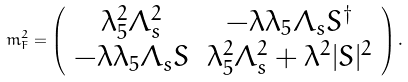<formula> <loc_0><loc_0><loc_500><loc_500>m _ { F } ^ { 2 } = \left ( \begin{array} { c c } \lambda _ { 5 } ^ { 2 } \Lambda _ { s } ^ { 2 } & - \lambda \lambda _ { 5 } \Lambda _ { s } S ^ { \dagger } \\ - \lambda \lambda _ { 5 } \Lambda _ { s } S & \lambda _ { 5 } ^ { 2 } \Lambda _ { s } ^ { 2 } + \lambda ^ { 2 } | S | ^ { 2 } \end{array} \right ) .</formula> 